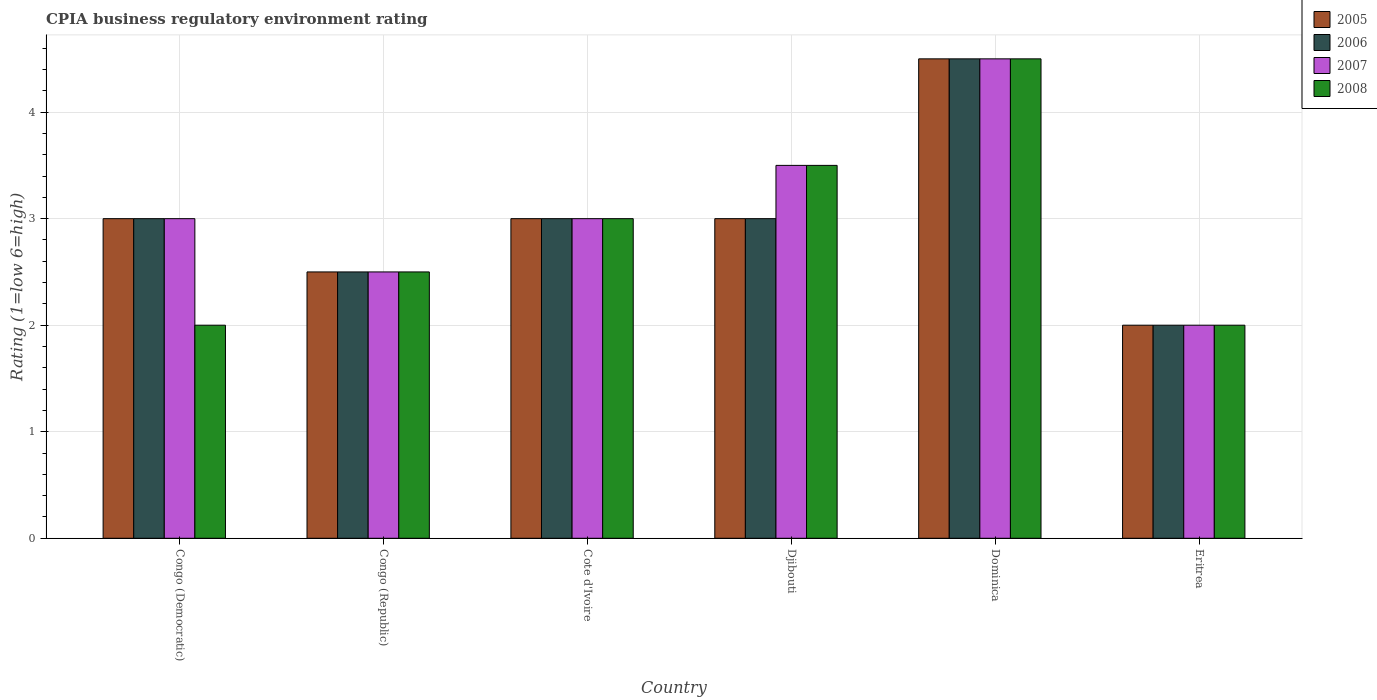How many groups of bars are there?
Offer a terse response. 6. What is the label of the 3rd group of bars from the left?
Keep it short and to the point. Cote d'Ivoire. Across all countries, what is the maximum CPIA rating in 2006?
Your answer should be very brief. 4.5. Across all countries, what is the minimum CPIA rating in 2006?
Your answer should be compact. 2. In which country was the CPIA rating in 2005 maximum?
Offer a very short reply. Dominica. In which country was the CPIA rating in 2006 minimum?
Provide a succinct answer. Eritrea. What is the difference between the CPIA rating in 2006 in Dominica and that in Eritrea?
Your response must be concise. 2.5. What is the difference between the CPIA rating in 2007 in Eritrea and the CPIA rating in 2008 in Djibouti?
Provide a succinct answer. -1.5. What is the average CPIA rating in 2008 per country?
Your answer should be very brief. 2.92. What is the difference between the CPIA rating of/in 2007 and CPIA rating of/in 2006 in Djibouti?
Make the answer very short. 0.5. What is the ratio of the CPIA rating in 2008 in Congo (Republic) to that in Cote d'Ivoire?
Provide a short and direct response. 0.83. Is the CPIA rating in 2008 in Congo (Republic) less than that in Cote d'Ivoire?
Your answer should be very brief. Yes. Is the difference between the CPIA rating in 2007 in Cote d'Ivoire and Eritrea greater than the difference between the CPIA rating in 2006 in Cote d'Ivoire and Eritrea?
Offer a very short reply. No. What is the difference between the highest and the second highest CPIA rating in 2006?
Ensure brevity in your answer.  -1.5. What is the difference between the highest and the lowest CPIA rating in 2006?
Your response must be concise. 2.5. Is it the case that in every country, the sum of the CPIA rating in 2005 and CPIA rating in 2008 is greater than the sum of CPIA rating in 2006 and CPIA rating in 2007?
Provide a succinct answer. No. What does the 4th bar from the right in Cote d'Ivoire represents?
Your answer should be very brief. 2005. Is it the case that in every country, the sum of the CPIA rating in 2005 and CPIA rating in 2008 is greater than the CPIA rating in 2006?
Make the answer very short. Yes. How many countries are there in the graph?
Your answer should be very brief. 6. What is the difference between two consecutive major ticks on the Y-axis?
Provide a succinct answer. 1. Are the values on the major ticks of Y-axis written in scientific E-notation?
Make the answer very short. No. Does the graph contain any zero values?
Make the answer very short. No. Does the graph contain grids?
Offer a very short reply. Yes. How are the legend labels stacked?
Provide a short and direct response. Vertical. What is the title of the graph?
Provide a succinct answer. CPIA business regulatory environment rating. What is the label or title of the Y-axis?
Give a very brief answer. Rating (1=low 6=high). What is the Rating (1=low 6=high) in 2005 in Congo (Democratic)?
Provide a short and direct response. 3. What is the Rating (1=low 6=high) in 2007 in Congo (Republic)?
Offer a very short reply. 2.5. What is the Rating (1=low 6=high) of 2008 in Congo (Republic)?
Provide a short and direct response. 2.5. What is the Rating (1=low 6=high) of 2007 in Cote d'Ivoire?
Your answer should be very brief. 3. What is the Rating (1=low 6=high) in 2008 in Cote d'Ivoire?
Provide a short and direct response. 3. What is the Rating (1=low 6=high) in 2005 in Djibouti?
Your answer should be compact. 3. What is the Rating (1=low 6=high) of 2006 in Djibouti?
Offer a terse response. 3. What is the Rating (1=low 6=high) in 2008 in Djibouti?
Your answer should be compact. 3.5. What is the Rating (1=low 6=high) in 2007 in Dominica?
Offer a very short reply. 4.5. What is the Rating (1=low 6=high) of 2007 in Eritrea?
Your answer should be compact. 2. What is the Rating (1=low 6=high) of 2008 in Eritrea?
Keep it short and to the point. 2. Across all countries, what is the maximum Rating (1=low 6=high) in 2006?
Provide a short and direct response. 4.5. Across all countries, what is the maximum Rating (1=low 6=high) of 2007?
Keep it short and to the point. 4.5. Across all countries, what is the minimum Rating (1=low 6=high) of 2005?
Give a very brief answer. 2. What is the total Rating (1=low 6=high) of 2005 in the graph?
Make the answer very short. 18. What is the total Rating (1=low 6=high) of 2006 in the graph?
Offer a very short reply. 18. What is the difference between the Rating (1=low 6=high) of 2006 in Congo (Democratic) and that in Congo (Republic)?
Offer a very short reply. 0.5. What is the difference between the Rating (1=low 6=high) in 2005 in Congo (Democratic) and that in Cote d'Ivoire?
Your answer should be very brief. 0. What is the difference between the Rating (1=low 6=high) in 2006 in Congo (Democratic) and that in Cote d'Ivoire?
Offer a terse response. 0. What is the difference between the Rating (1=low 6=high) of 2008 in Congo (Democratic) and that in Cote d'Ivoire?
Keep it short and to the point. -1. What is the difference between the Rating (1=low 6=high) of 2006 in Congo (Democratic) and that in Djibouti?
Your answer should be compact. 0. What is the difference between the Rating (1=low 6=high) in 2007 in Congo (Democratic) and that in Djibouti?
Provide a succinct answer. -0.5. What is the difference between the Rating (1=low 6=high) of 2006 in Congo (Democratic) and that in Dominica?
Give a very brief answer. -1.5. What is the difference between the Rating (1=low 6=high) of 2007 in Congo (Democratic) and that in Eritrea?
Provide a succinct answer. 1. What is the difference between the Rating (1=low 6=high) of 2008 in Congo (Republic) and that in Cote d'Ivoire?
Your response must be concise. -0.5. What is the difference between the Rating (1=low 6=high) in 2006 in Congo (Republic) and that in Djibouti?
Provide a succinct answer. -0.5. What is the difference between the Rating (1=low 6=high) in 2008 in Congo (Republic) and that in Djibouti?
Ensure brevity in your answer.  -1. What is the difference between the Rating (1=low 6=high) in 2005 in Congo (Republic) and that in Dominica?
Provide a succinct answer. -2. What is the difference between the Rating (1=low 6=high) in 2007 in Congo (Republic) and that in Dominica?
Your answer should be very brief. -2. What is the difference between the Rating (1=low 6=high) in 2006 in Congo (Republic) and that in Eritrea?
Your answer should be compact. 0.5. What is the difference between the Rating (1=low 6=high) in 2008 in Congo (Republic) and that in Eritrea?
Provide a succinct answer. 0.5. What is the difference between the Rating (1=low 6=high) of 2005 in Cote d'Ivoire and that in Djibouti?
Offer a very short reply. 0. What is the difference between the Rating (1=low 6=high) in 2007 in Cote d'Ivoire and that in Djibouti?
Your response must be concise. -0.5. What is the difference between the Rating (1=low 6=high) of 2008 in Cote d'Ivoire and that in Djibouti?
Provide a short and direct response. -0.5. What is the difference between the Rating (1=low 6=high) in 2005 in Cote d'Ivoire and that in Dominica?
Keep it short and to the point. -1.5. What is the difference between the Rating (1=low 6=high) of 2006 in Cote d'Ivoire and that in Dominica?
Offer a terse response. -1.5. What is the difference between the Rating (1=low 6=high) in 2007 in Cote d'Ivoire and that in Dominica?
Keep it short and to the point. -1.5. What is the difference between the Rating (1=low 6=high) in 2008 in Cote d'Ivoire and that in Dominica?
Provide a short and direct response. -1.5. What is the difference between the Rating (1=low 6=high) in 2005 in Cote d'Ivoire and that in Eritrea?
Offer a very short reply. 1. What is the difference between the Rating (1=low 6=high) of 2006 in Cote d'Ivoire and that in Eritrea?
Offer a terse response. 1. What is the difference between the Rating (1=low 6=high) in 2007 in Cote d'Ivoire and that in Eritrea?
Make the answer very short. 1. What is the difference between the Rating (1=low 6=high) in 2008 in Cote d'Ivoire and that in Eritrea?
Make the answer very short. 1. What is the difference between the Rating (1=low 6=high) of 2005 in Djibouti and that in Eritrea?
Offer a very short reply. 1. What is the difference between the Rating (1=low 6=high) of 2006 in Djibouti and that in Eritrea?
Make the answer very short. 1. What is the difference between the Rating (1=low 6=high) of 2007 in Djibouti and that in Eritrea?
Give a very brief answer. 1.5. What is the difference between the Rating (1=low 6=high) in 2005 in Congo (Democratic) and the Rating (1=low 6=high) in 2006 in Congo (Republic)?
Make the answer very short. 0.5. What is the difference between the Rating (1=low 6=high) in 2005 in Congo (Democratic) and the Rating (1=low 6=high) in 2007 in Congo (Republic)?
Your answer should be compact. 0.5. What is the difference between the Rating (1=low 6=high) in 2005 in Congo (Democratic) and the Rating (1=low 6=high) in 2008 in Congo (Republic)?
Offer a terse response. 0.5. What is the difference between the Rating (1=low 6=high) in 2006 in Congo (Democratic) and the Rating (1=low 6=high) in 2007 in Congo (Republic)?
Offer a very short reply. 0.5. What is the difference between the Rating (1=low 6=high) of 2006 in Congo (Democratic) and the Rating (1=low 6=high) of 2008 in Congo (Republic)?
Offer a very short reply. 0.5. What is the difference between the Rating (1=low 6=high) in 2007 in Congo (Democratic) and the Rating (1=low 6=high) in 2008 in Congo (Republic)?
Your answer should be very brief. 0.5. What is the difference between the Rating (1=low 6=high) in 2006 in Congo (Democratic) and the Rating (1=low 6=high) in 2008 in Cote d'Ivoire?
Keep it short and to the point. 0. What is the difference between the Rating (1=low 6=high) in 2005 in Congo (Democratic) and the Rating (1=low 6=high) in 2006 in Djibouti?
Your response must be concise. 0. What is the difference between the Rating (1=low 6=high) in 2007 in Congo (Democratic) and the Rating (1=low 6=high) in 2008 in Djibouti?
Provide a succinct answer. -0.5. What is the difference between the Rating (1=low 6=high) in 2005 in Congo (Democratic) and the Rating (1=low 6=high) in 2006 in Dominica?
Your answer should be very brief. -1.5. What is the difference between the Rating (1=low 6=high) in 2005 in Congo (Democratic) and the Rating (1=low 6=high) in 2007 in Dominica?
Your response must be concise. -1.5. What is the difference between the Rating (1=low 6=high) of 2006 in Congo (Democratic) and the Rating (1=low 6=high) of 2007 in Dominica?
Give a very brief answer. -1.5. What is the difference between the Rating (1=low 6=high) of 2007 in Congo (Democratic) and the Rating (1=low 6=high) of 2008 in Dominica?
Provide a succinct answer. -1.5. What is the difference between the Rating (1=low 6=high) in 2005 in Congo (Democratic) and the Rating (1=low 6=high) in 2008 in Eritrea?
Provide a short and direct response. 1. What is the difference between the Rating (1=low 6=high) of 2006 in Congo (Democratic) and the Rating (1=low 6=high) of 2008 in Eritrea?
Give a very brief answer. 1. What is the difference between the Rating (1=low 6=high) of 2005 in Congo (Republic) and the Rating (1=low 6=high) of 2007 in Cote d'Ivoire?
Provide a succinct answer. -0.5. What is the difference between the Rating (1=low 6=high) in 2005 in Congo (Republic) and the Rating (1=low 6=high) in 2006 in Djibouti?
Make the answer very short. -0.5. What is the difference between the Rating (1=low 6=high) of 2005 in Congo (Republic) and the Rating (1=low 6=high) of 2007 in Djibouti?
Provide a succinct answer. -1. What is the difference between the Rating (1=low 6=high) of 2006 in Congo (Republic) and the Rating (1=low 6=high) of 2007 in Djibouti?
Offer a very short reply. -1. What is the difference between the Rating (1=low 6=high) in 2006 in Congo (Republic) and the Rating (1=low 6=high) in 2008 in Djibouti?
Your answer should be very brief. -1. What is the difference between the Rating (1=low 6=high) in 2007 in Congo (Republic) and the Rating (1=low 6=high) in 2008 in Djibouti?
Keep it short and to the point. -1. What is the difference between the Rating (1=low 6=high) of 2005 in Congo (Republic) and the Rating (1=low 6=high) of 2006 in Dominica?
Offer a terse response. -2. What is the difference between the Rating (1=low 6=high) in 2005 in Congo (Republic) and the Rating (1=low 6=high) in 2008 in Dominica?
Your answer should be compact. -2. What is the difference between the Rating (1=low 6=high) in 2006 in Congo (Republic) and the Rating (1=low 6=high) in 2007 in Dominica?
Your answer should be compact. -2. What is the difference between the Rating (1=low 6=high) of 2006 in Congo (Republic) and the Rating (1=low 6=high) of 2008 in Dominica?
Ensure brevity in your answer.  -2. What is the difference between the Rating (1=low 6=high) in 2007 in Congo (Republic) and the Rating (1=low 6=high) in 2008 in Dominica?
Offer a terse response. -2. What is the difference between the Rating (1=low 6=high) of 2005 in Congo (Republic) and the Rating (1=low 6=high) of 2006 in Eritrea?
Keep it short and to the point. 0.5. What is the difference between the Rating (1=low 6=high) of 2005 in Congo (Republic) and the Rating (1=low 6=high) of 2008 in Eritrea?
Offer a very short reply. 0.5. What is the difference between the Rating (1=low 6=high) of 2006 in Congo (Republic) and the Rating (1=low 6=high) of 2008 in Eritrea?
Your answer should be very brief. 0.5. What is the difference between the Rating (1=low 6=high) of 2007 in Congo (Republic) and the Rating (1=low 6=high) of 2008 in Eritrea?
Provide a short and direct response. 0.5. What is the difference between the Rating (1=low 6=high) of 2005 in Cote d'Ivoire and the Rating (1=low 6=high) of 2007 in Djibouti?
Offer a very short reply. -0.5. What is the difference between the Rating (1=low 6=high) of 2005 in Cote d'Ivoire and the Rating (1=low 6=high) of 2008 in Djibouti?
Make the answer very short. -0.5. What is the difference between the Rating (1=low 6=high) of 2006 in Cote d'Ivoire and the Rating (1=low 6=high) of 2008 in Djibouti?
Provide a short and direct response. -0.5. What is the difference between the Rating (1=low 6=high) of 2007 in Cote d'Ivoire and the Rating (1=low 6=high) of 2008 in Djibouti?
Your answer should be compact. -0.5. What is the difference between the Rating (1=low 6=high) of 2005 in Cote d'Ivoire and the Rating (1=low 6=high) of 2006 in Dominica?
Make the answer very short. -1.5. What is the difference between the Rating (1=low 6=high) of 2005 in Cote d'Ivoire and the Rating (1=low 6=high) of 2007 in Dominica?
Your answer should be very brief. -1.5. What is the difference between the Rating (1=low 6=high) in 2006 in Cote d'Ivoire and the Rating (1=low 6=high) in 2007 in Dominica?
Provide a succinct answer. -1.5. What is the difference between the Rating (1=low 6=high) of 2005 in Cote d'Ivoire and the Rating (1=low 6=high) of 2007 in Eritrea?
Your answer should be very brief. 1. What is the difference between the Rating (1=low 6=high) in 2005 in Cote d'Ivoire and the Rating (1=low 6=high) in 2008 in Eritrea?
Your answer should be compact. 1. What is the difference between the Rating (1=low 6=high) of 2006 in Cote d'Ivoire and the Rating (1=low 6=high) of 2008 in Eritrea?
Your answer should be very brief. 1. What is the difference between the Rating (1=low 6=high) of 2007 in Cote d'Ivoire and the Rating (1=low 6=high) of 2008 in Eritrea?
Your response must be concise. 1. What is the difference between the Rating (1=low 6=high) of 2005 in Djibouti and the Rating (1=low 6=high) of 2006 in Dominica?
Provide a short and direct response. -1.5. What is the difference between the Rating (1=low 6=high) in 2006 in Djibouti and the Rating (1=low 6=high) in 2007 in Dominica?
Offer a very short reply. -1.5. What is the difference between the Rating (1=low 6=high) of 2006 in Djibouti and the Rating (1=low 6=high) of 2008 in Dominica?
Make the answer very short. -1.5. What is the difference between the Rating (1=low 6=high) in 2007 in Djibouti and the Rating (1=low 6=high) in 2008 in Dominica?
Keep it short and to the point. -1. What is the difference between the Rating (1=low 6=high) in 2005 in Djibouti and the Rating (1=low 6=high) in 2006 in Eritrea?
Offer a very short reply. 1. What is the difference between the Rating (1=low 6=high) in 2005 in Djibouti and the Rating (1=low 6=high) in 2007 in Eritrea?
Your answer should be very brief. 1. What is the difference between the Rating (1=low 6=high) in 2005 in Djibouti and the Rating (1=low 6=high) in 2008 in Eritrea?
Your answer should be compact. 1. What is the difference between the Rating (1=low 6=high) in 2006 in Djibouti and the Rating (1=low 6=high) in 2007 in Eritrea?
Your answer should be very brief. 1. What is the difference between the Rating (1=low 6=high) in 2005 in Dominica and the Rating (1=low 6=high) in 2007 in Eritrea?
Your answer should be very brief. 2.5. What is the difference between the Rating (1=low 6=high) of 2006 in Dominica and the Rating (1=low 6=high) of 2007 in Eritrea?
Provide a succinct answer. 2.5. What is the difference between the Rating (1=low 6=high) of 2006 in Dominica and the Rating (1=low 6=high) of 2008 in Eritrea?
Keep it short and to the point. 2.5. What is the difference between the Rating (1=low 6=high) of 2007 in Dominica and the Rating (1=low 6=high) of 2008 in Eritrea?
Your answer should be very brief. 2.5. What is the average Rating (1=low 6=high) in 2007 per country?
Keep it short and to the point. 3.08. What is the average Rating (1=low 6=high) of 2008 per country?
Keep it short and to the point. 2.92. What is the difference between the Rating (1=low 6=high) in 2005 and Rating (1=low 6=high) in 2006 in Congo (Democratic)?
Offer a terse response. 0. What is the difference between the Rating (1=low 6=high) in 2005 and Rating (1=low 6=high) in 2008 in Congo (Democratic)?
Give a very brief answer. 1. What is the difference between the Rating (1=low 6=high) in 2005 and Rating (1=low 6=high) in 2006 in Congo (Republic)?
Offer a very short reply. 0. What is the difference between the Rating (1=low 6=high) of 2005 and Rating (1=low 6=high) of 2008 in Congo (Republic)?
Provide a short and direct response. 0. What is the difference between the Rating (1=low 6=high) of 2005 and Rating (1=low 6=high) of 2006 in Cote d'Ivoire?
Offer a terse response. 0. What is the difference between the Rating (1=low 6=high) in 2006 and Rating (1=low 6=high) in 2008 in Cote d'Ivoire?
Ensure brevity in your answer.  0. What is the difference between the Rating (1=low 6=high) in 2005 and Rating (1=low 6=high) in 2006 in Djibouti?
Your answer should be compact. 0. What is the difference between the Rating (1=low 6=high) in 2006 and Rating (1=low 6=high) in 2007 in Djibouti?
Offer a very short reply. -0.5. What is the difference between the Rating (1=low 6=high) in 2006 and Rating (1=low 6=high) in 2008 in Djibouti?
Offer a very short reply. -0.5. What is the difference between the Rating (1=low 6=high) in 2006 and Rating (1=low 6=high) in 2007 in Dominica?
Your answer should be very brief. 0. What is the difference between the Rating (1=low 6=high) in 2005 and Rating (1=low 6=high) in 2006 in Eritrea?
Provide a short and direct response. 0. What is the difference between the Rating (1=low 6=high) in 2005 and Rating (1=low 6=high) in 2007 in Eritrea?
Give a very brief answer. 0. What is the difference between the Rating (1=low 6=high) of 2006 and Rating (1=low 6=high) of 2007 in Eritrea?
Your response must be concise. 0. What is the ratio of the Rating (1=low 6=high) in 2006 in Congo (Democratic) to that in Congo (Republic)?
Offer a terse response. 1.2. What is the ratio of the Rating (1=low 6=high) in 2007 in Congo (Democratic) to that in Congo (Republic)?
Your answer should be very brief. 1.2. What is the ratio of the Rating (1=low 6=high) in 2008 in Congo (Democratic) to that in Congo (Republic)?
Keep it short and to the point. 0.8. What is the ratio of the Rating (1=low 6=high) in 2005 in Congo (Democratic) to that in Cote d'Ivoire?
Offer a very short reply. 1. What is the ratio of the Rating (1=low 6=high) of 2008 in Congo (Democratic) to that in Cote d'Ivoire?
Provide a short and direct response. 0.67. What is the ratio of the Rating (1=low 6=high) of 2006 in Congo (Democratic) to that in Djibouti?
Ensure brevity in your answer.  1. What is the ratio of the Rating (1=low 6=high) in 2007 in Congo (Democratic) to that in Djibouti?
Give a very brief answer. 0.86. What is the ratio of the Rating (1=low 6=high) in 2008 in Congo (Democratic) to that in Djibouti?
Give a very brief answer. 0.57. What is the ratio of the Rating (1=low 6=high) in 2007 in Congo (Democratic) to that in Dominica?
Your answer should be compact. 0.67. What is the ratio of the Rating (1=low 6=high) in 2008 in Congo (Democratic) to that in Dominica?
Give a very brief answer. 0.44. What is the ratio of the Rating (1=low 6=high) of 2005 in Congo (Democratic) to that in Eritrea?
Provide a succinct answer. 1.5. What is the ratio of the Rating (1=low 6=high) of 2006 in Congo (Democratic) to that in Eritrea?
Your answer should be very brief. 1.5. What is the ratio of the Rating (1=low 6=high) of 2008 in Congo (Democratic) to that in Eritrea?
Make the answer very short. 1. What is the ratio of the Rating (1=low 6=high) of 2005 in Congo (Republic) to that in Cote d'Ivoire?
Provide a short and direct response. 0.83. What is the ratio of the Rating (1=low 6=high) in 2006 in Congo (Republic) to that in Cote d'Ivoire?
Keep it short and to the point. 0.83. What is the ratio of the Rating (1=low 6=high) of 2007 in Congo (Republic) to that in Cote d'Ivoire?
Your answer should be very brief. 0.83. What is the ratio of the Rating (1=low 6=high) in 2007 in Congo (Republic) to that in Djibouti?
Offer a terse response. 0.71. What is the ratio of the Rating (1=low 6=high) in 2005 in Congo (Republic) to that in Dominica?
Keep it short and to the point. 0.56. What is the ratio of the Rating (1=low 6=high) in 2006 in Congo (Republic) to that in Dominica?
Offer a very short reply. 0.56. What is the ratio of the Rating (1=low 6=high) in 2007 in Congo (Republic) to that in Dominica?
Your response must be concise. 0.56. What is the ratio of the Rating (1=low 6=high) of 2008 in Congo (Republic) to that in Dominica?
Provide a short and direct response. 0.56. What is the ratio of the Rating (1=low 6=high) in 2006 in Congo (Republic) to that in Eritrea?
Provide a succinct answer. 1.25. What is the ratio of the Rating (1=low 6=high) in 2007 in Congo (Republic) to that in Eritrea?
Offer a very short reply. 1.25. What is the ratio of the Rating (1=low 6=high) in 2005 in Cote d'Ivoire to that in Djibouti?
Keep it short and to the point. 1. What is the ratio of the Rating (1=low 6=high) in 2006 in Cote d'Ivoire to that in Djibouti?
Offer a very short reply. 1. What is the ratio of the Rating (1=low 6=high) of 2008 in Cote d'Ivoire to that in Djibouti?
Offer a terse response. 0.86. What is the ratio of the Rating (1=low 6=high) of 2005 in Cote d'Ivoire to that in Dominica?
Your answer should be compact. 0.67. What is the ratio of the Rating (1=low 6=high) in 2007 in Cote d'Ivoire to that in Dominica?
Offer a terse response. 0.67. What is the ratio of the Rating (1=low 6=high) in 2005 in Cote d'Ivoire to that in Eritrea?
Ensure brevity in your answer.  1.5. What is the ratio of the Rating (1=low 6=high) of 2007 in Djibouti to that in Dominica?
Offer a very short reply. 0.78. What is the ratio of the Rating (1=low 6=high) of 2008 in Djibouti to that in Dominica?
Offer a very short reply. 0.78. What is the ratio of the Rating (1=low 6=high) in 2007 in Djibouti to that in Eritrea?
Ensure brevity in your answer.  1.75. What is the ratio of the Rating (1=low 6=high) in 2008 in Djibouti to that in Eritrea?
Offer a very short reply. 1.75. What is the ratio of the Rating (1=low 6=high) in 2005 in Dominica to that in Eritrea?
Your answer should be compact. 2.25. What is the ratio of the Rating (1=low 6=high) in 2006 in Dominica to that in Eritrea?
Your answer should be compact. 2.25. What is the ratio of the Rating (1=low 6=high) of 2007 in Dominica to that in Eritrea?
Offer a terse response. 2.25. What is the ratio of the Rating (1=low 6=high) in 2008 in Dominica to that in Eritrea?
Offer a terse response. 2.25. What is the difference between the highest and the second highest Rating (1=low 6=high) in 2007?
Provide a short and direct response. 1. What is the difference between the highest and the second highest Rating (1=low 6=high) of 2008?
Your response must be concise. 1. What is the difference between the highest and the lowest Rating (1=low 6=high) in 2005?
Offer a very short reply. 2.5. 